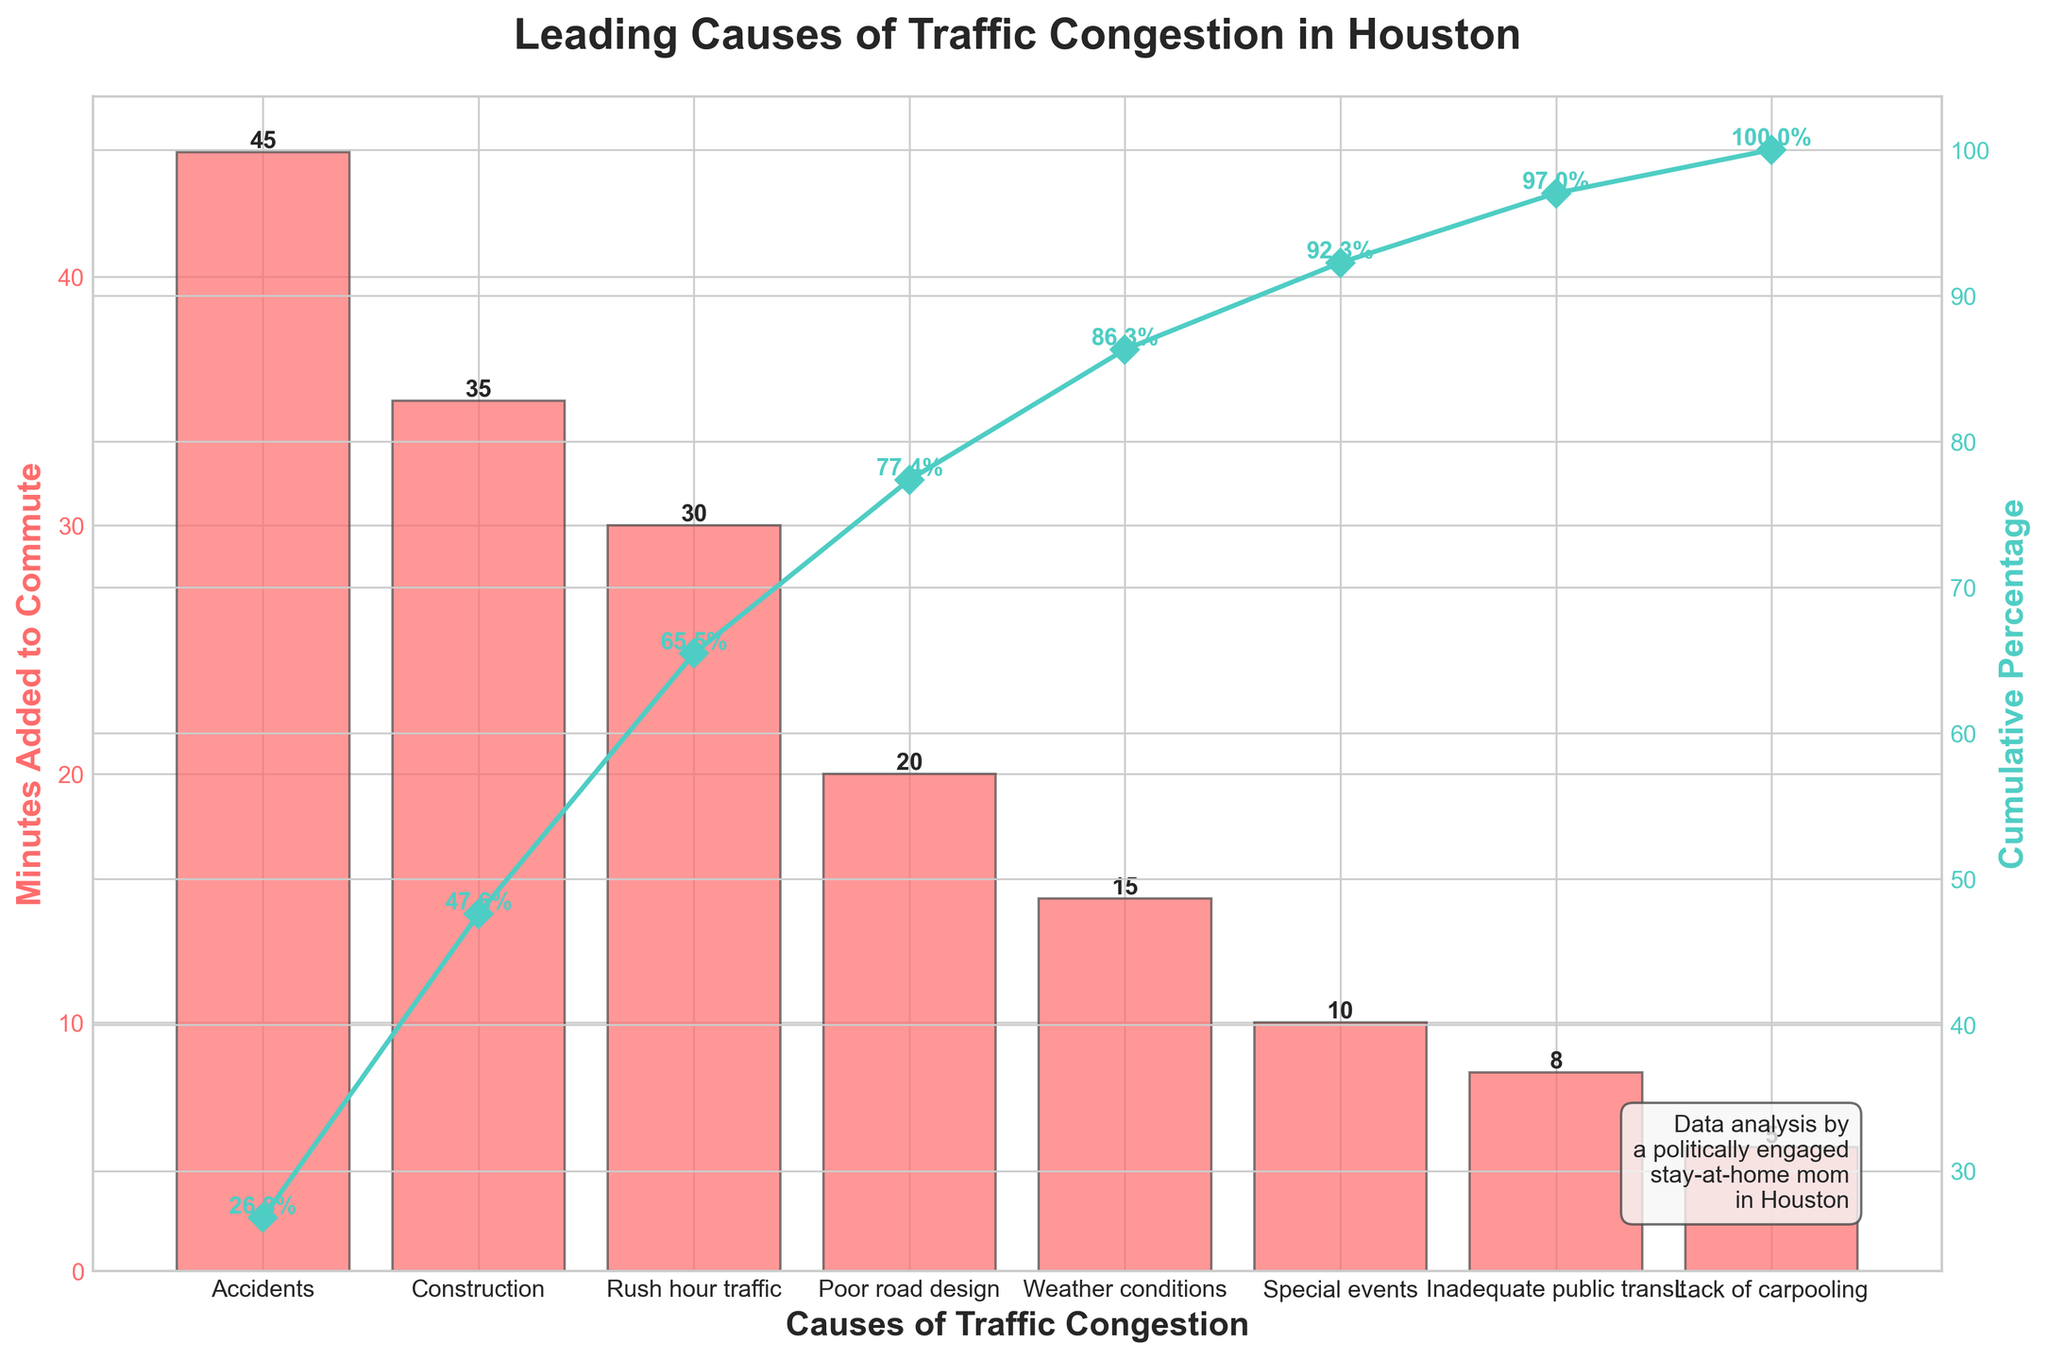How many causes of traffic congestion are shown on the chart? The causes of traffic congestion can be counted from the x-axis labels; each bar label corresponds to one cause.
Answer: 8 Which cause adds the most minutes to commute times? The highest bar on the chart represents the cause with the most minutes added to commute times.
Answer: Accidents What is the cumulative percentage for the top three causes of congestion? The cumulative percentages for the top three causes, Accidents, Construction, and Rush hour traffic, are summed: 30 (Accidents) + 23.33 (Construction) + 20 (Rush hour traffic).
Answer: 95.0% How does weather conditions’ impact on commute times compare to special events? Weather conditions and special events can be compared by looking at the height of their respective bars. The "Minutes Added to Commute" for Weather conditions (15) is greater than Special events (10).
Answer: Weather conditions have a larger impact What percentage of the total impact is contributed by construction and inadequate public transit combined? First, find the individual percentages: 23.33% for Construction and 5.33% for Inadequate public transit. Sum these percentages: 23.33 + 5.33.
Answer: 28.66% What is the approximate cumulative percentage after including poor road design? Add the cumulative percentage of Poor road design to that of the preceding causes: 95 (Rush hour traffic) + 11.67 (Poor road design).
Answer: 50.0% If inadequate public transit is improved and commute time impact drops to 0, what will be the new cumulative percentage for the remaining causes? Exclude Inadequate public transit from the total sum and recalculate cumulative percentages for the remaining causes, redistribute proportionally excluding the 5% impact.
Answer: The adjusted cumulative percentages should be recalculated What is the median value of 'Minutes Added to Commute' for the causes listed? The median value is the middle number in a sorted list: the sorted values are 5, 8, 10, 15, 20, 30, 35, 45. Hence, the median is (20 + 30) / 2 = 25
Answer: 25 minutes 